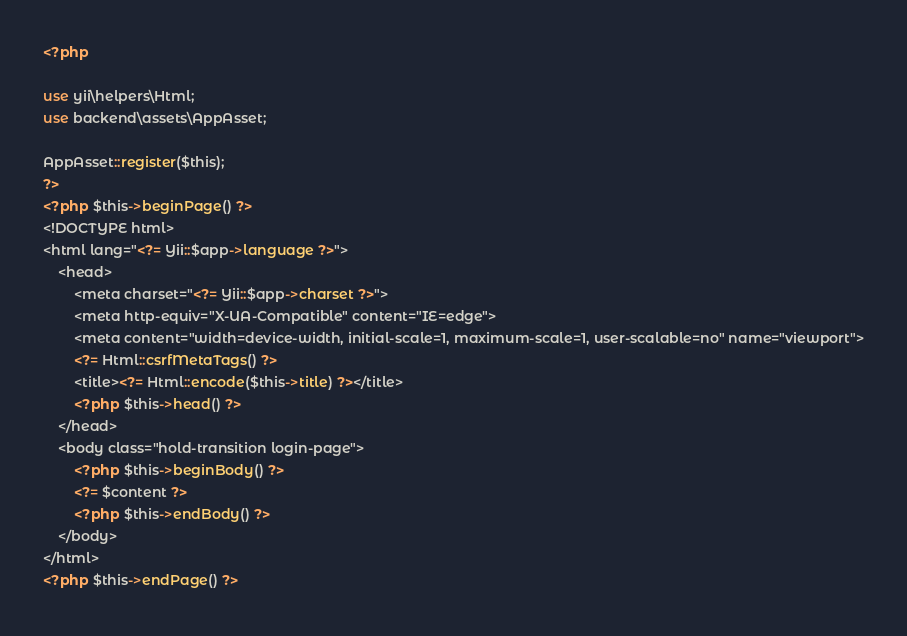Convert code to text. <code><loc_0><loc_0><loc_500><loc_500><_PHP_><?php

use yii\helpers\Html;
use backend\assets\AppAsset;

AppAsset::register($this);
?>
<?php $this->beginPage() ?>
<!DOCTYPE html>
<html lang="<?= Yii::$app->language ?>">
    <head>
        <meta charset="<?= Yii::$app->charset ?>">
        <meta http-equiv="X-UA-Compatible" content="IE=edge">
        <meta content="width=device-width, initial-scale=1, maximum-scale=1, user-scalable=no" name="viewport">
        <?= Html::csrfMetaTags() ?>
        <title><?= Html::encode($this->title) ?></title>
        <?php $this->head() ?>
    </head>
    <body class="hold-transition login-page">
        <?php $this->beginBody() ?>
        <?= $content ?>
        <?php $this->endBody() ?>
    </body>
</html>
<?php $this->endPage() ?></code> 